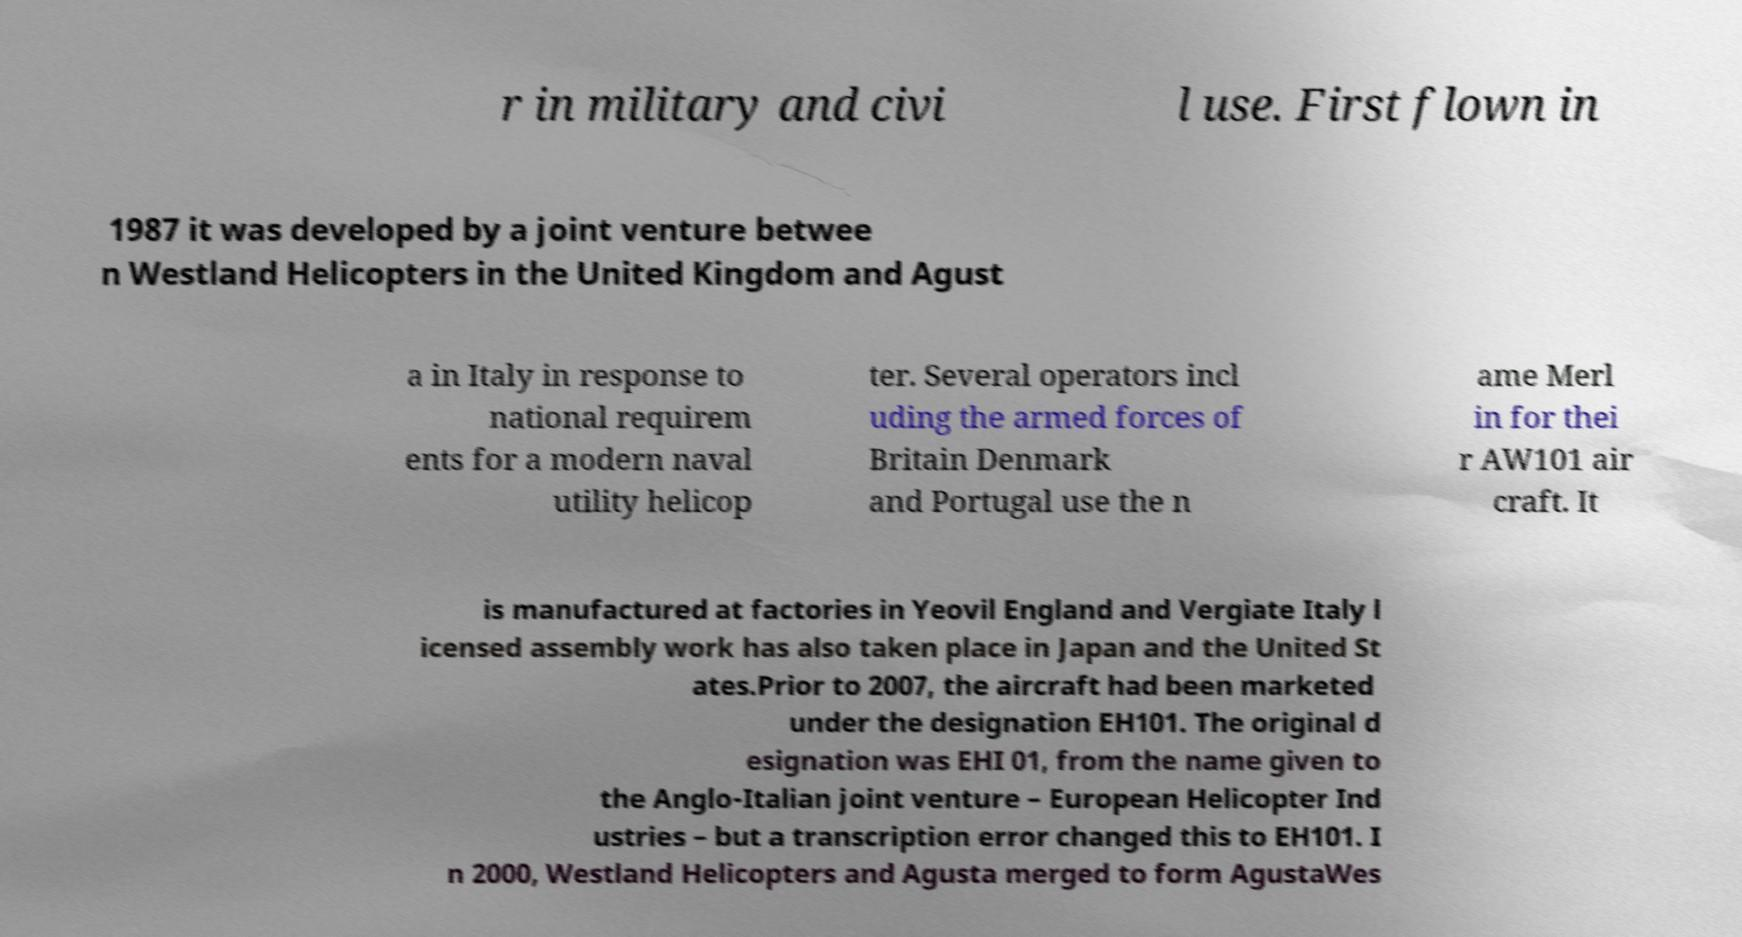Can you accurately transcribe the text from the provided image for me? r in military and civi l use. First flown in 1987 it was developed by a joint venture betwee n Westland Helicopters in the United Kingdom and Agust a in Italy in response to national requirem ents for a modern naval utility helicop ter. Several operators incl uding the armed forces of Britain Denmark and Portugal use the n ame Merl in for thei r AW101 air craft. It is manufactured at factories in Yeovil England and Vergiate Italy l icensed assembly work has also taken place in Japan and the United St ates.Prior to 2007, the aircraft had been marketed under the designation EH101. The original d esignation was EHI 01, from the name given to the Anglo-Italian joint venture – European Helicopter Ind ustries – but a transcription error changed this to EH101. I n 2000, Westland Helicopters and Agusta merged to form AgustaWes 